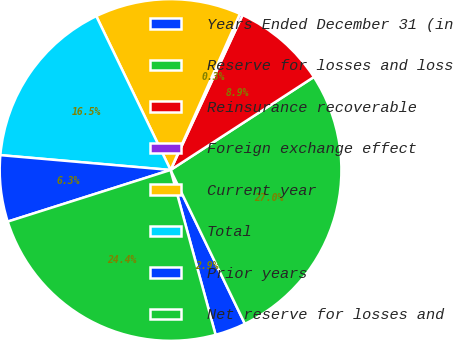<chart> <loc_0><loc_0><loc_500><loc_500><pie_chart><fcel>Years Ended December 31 (in<fcel>Reserve for losses and loss<fcel>Reinsurance recoverable<fcel>Foreign exchange effect<fcel>Current year<fcel>Total<fcel>Prior years<fcel>Net reserve for losses and<nl><fcel>2.92%<fcel>27.0%<fcel>8.92%<fcel>0.27%<fcel>13.81%<fcel>16.46%<fcel>6.27%<fcel>24.36%<nl></chart> 